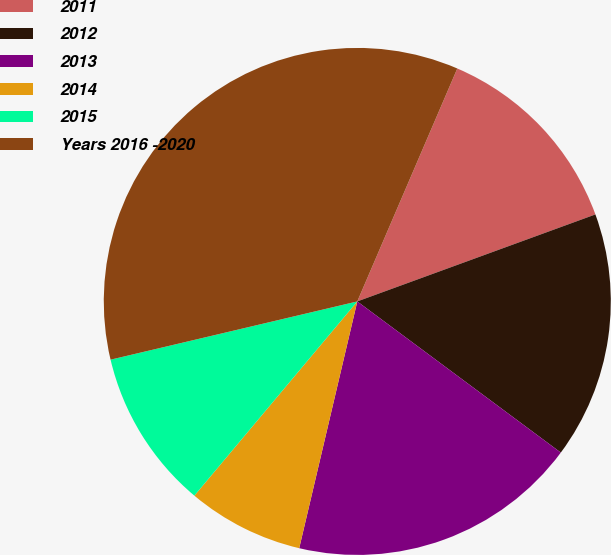Convert chart. <chart><loc_0><loc_0><loc_500><loc_500><pie_chart><fcel>2011<fcel>2012<fcel>2013<fcel>2014<fcel>2015<fcel>Years 2016 -2020<nl><fcel>12.97%<fcel>15.74%<fcel>18.51%<fcel>7.43%<fcel>10.2%<fcel>35.14%<nl></chart> 